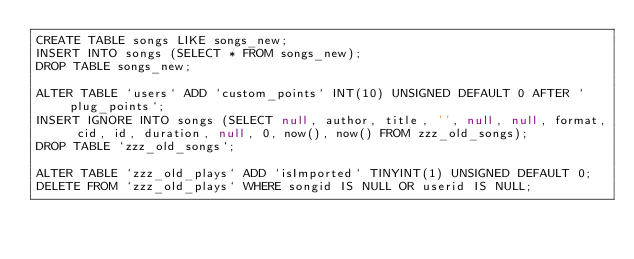Convert code to text. <code><loc_0><loc_0><loc_500><loc_500><_SQL_>CREATE TABLE songs LIKE songs_new;
INSERT INTO songs (SELECT * FROM songs_new);
DROP TABLE songs_new;

ALTER TABLE `users` ADD `custom_points` INT(10) UNSIGNED DEFAULT 0 AFTER `plug_points`;
INSERT IGNORE INTO songs (SELECT null, author, title, '', null, null, format, cid, id, duration, null, 0, now(), now() FROM zzz_old_songs);
DROP TABLE `zzz_old_songs`;

ALTER TABLE `zzz_old_plays` ADD `isImported` TINYINT(1) UNSIGNED DEFAULT 0;
DELETE FROM `zzz_old_plays` WHERE songid IS NULL OR userid IS NULL;</code> 